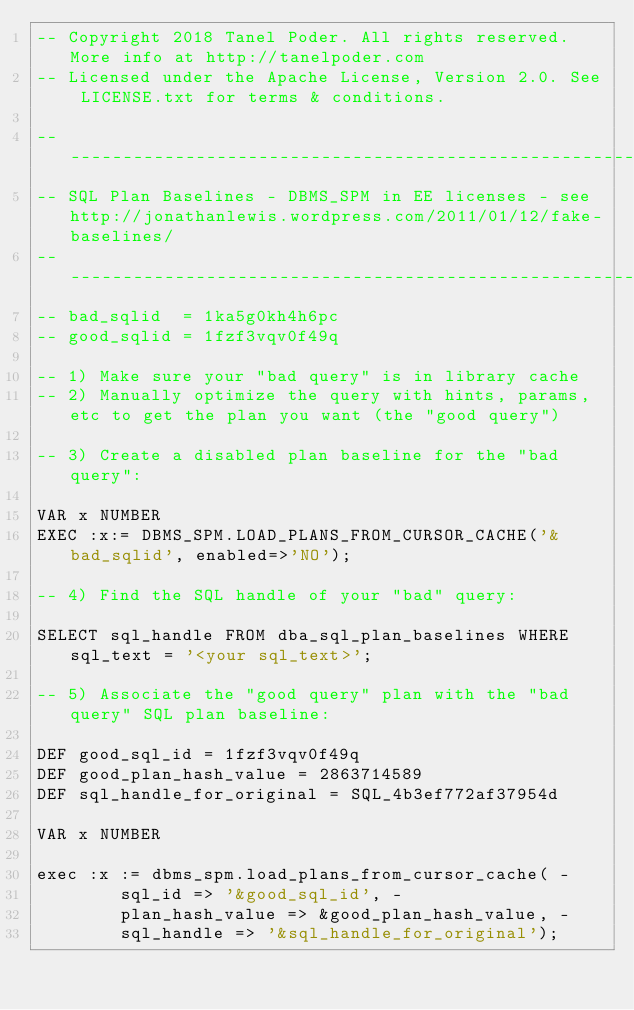Convert code to text. <code><loc_0><loc_0><loc_500><loc_500><_SQL_>-- Copyright 2018 Tanel Poder. All rights reserved. More info at http://tanelpoder.com
-- Licensed under the Apache License, Version 2.0. See LICENSE.txt for terms & conditions.

--------------------------------------------------------------------------------------------------------
-- SQL Plan Baselines - DBMS_SPM in EE licenses - see http://jonathanlewis.wordpress.com/2011/01/12/fake-baselines/
--------------------------------------------------------------------------------------------------------
-- bad_sqlid  = 1ka5g0kh4h6pc
-- good_sqlid = 1fzf3vqv0f49q 

-- 1) Make sure your "bad query" is in library cache
-- 2) Manually optimize the query with hints, params, etc to get the plan you want (the "good query")

-- 3) Create a disabled plan baseline for the "bad query":

VAR x NUMBER
EXEC :x:= DBMS_SPM.LOAD_PLANS_FROM_CURSOR_CACHE('&bad_sqlid', enabled=>'NO');

-- 4) Find the SQL handle of your "bad" query:

SELECT sql_handle FROM dba_sql_plan_baselines WHERE sql_text = '<your sql_text>';

-- 5) Associate the "good query" plan with the "bad query" SQL plan baseline:

DEF good_sql_id = 1fzf3vqv0f49q
DEF good_plan_hash_value = 2863714589
DEF sql_handle_for_original = SQL_4b3ef772af37954d

VAR x NUMBER

exec :x := dbms_spm.load_plans_from_cursor_cache( -
        sql_id => '&good_sql_id', -
        plan_hash_value => &good_plan_hash_value, -
        sql_handle => '&sql_handle_for_original');

</code> 